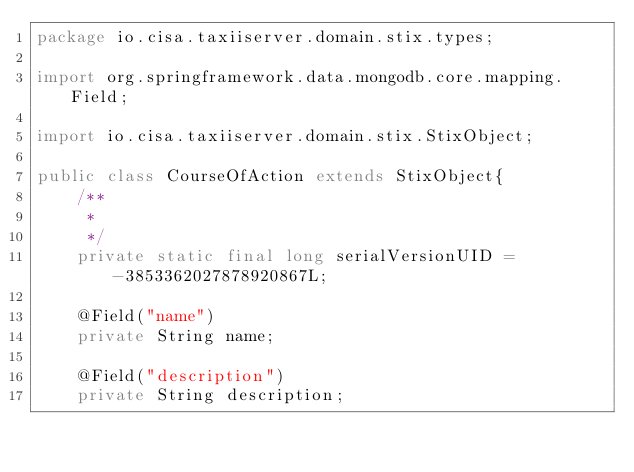Convert code to text. <code><loc_0><loc_0><loc_500><loc_500><_Java_>package io.cisa.taxiiserver.domain.stix.types;

import org.springframework.data.mongodb.core.mapping.Field;

import io.cisa.taxiiserver.domain.stix.StixObject;

public class CourseOfAction extends StixObject{
	/**
	 * 
	 */
	private static final long serialVersionUID = -3853362027878920867L;

	@Field("name")
	private String name;
	
	@Field("description")
	private String description;
	</code> 